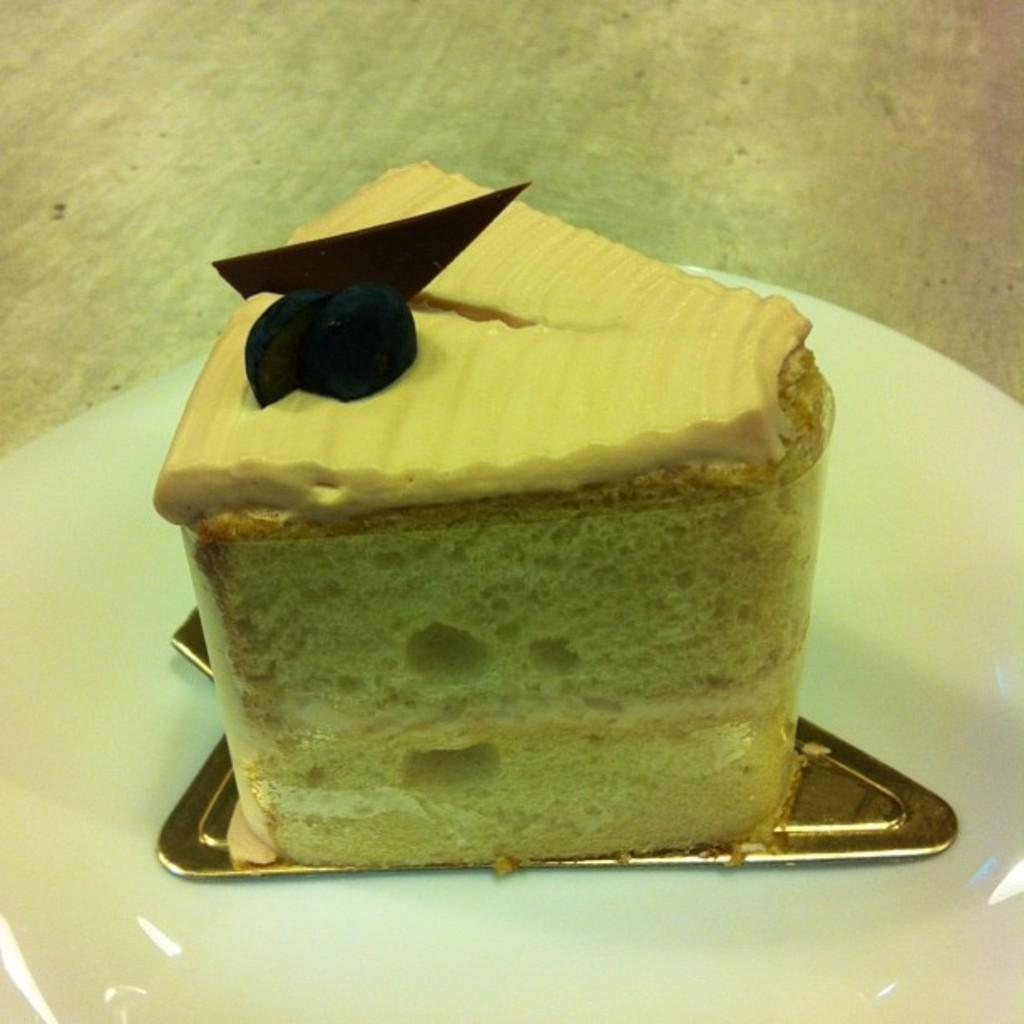What is the main subject of the image? The main subject of the image is a piece of cake. How is the cake positioned in the image? The cake is on a plate in the image. Where is the plate located in the image? The plate is in the center of the image. What type of horse can be seen in the image? There is no horse present in the image; it features a piece of cake on a plate. How is the ice being used in the image? There is no ice present in the image; it only shows a piece of cake on a plate. 